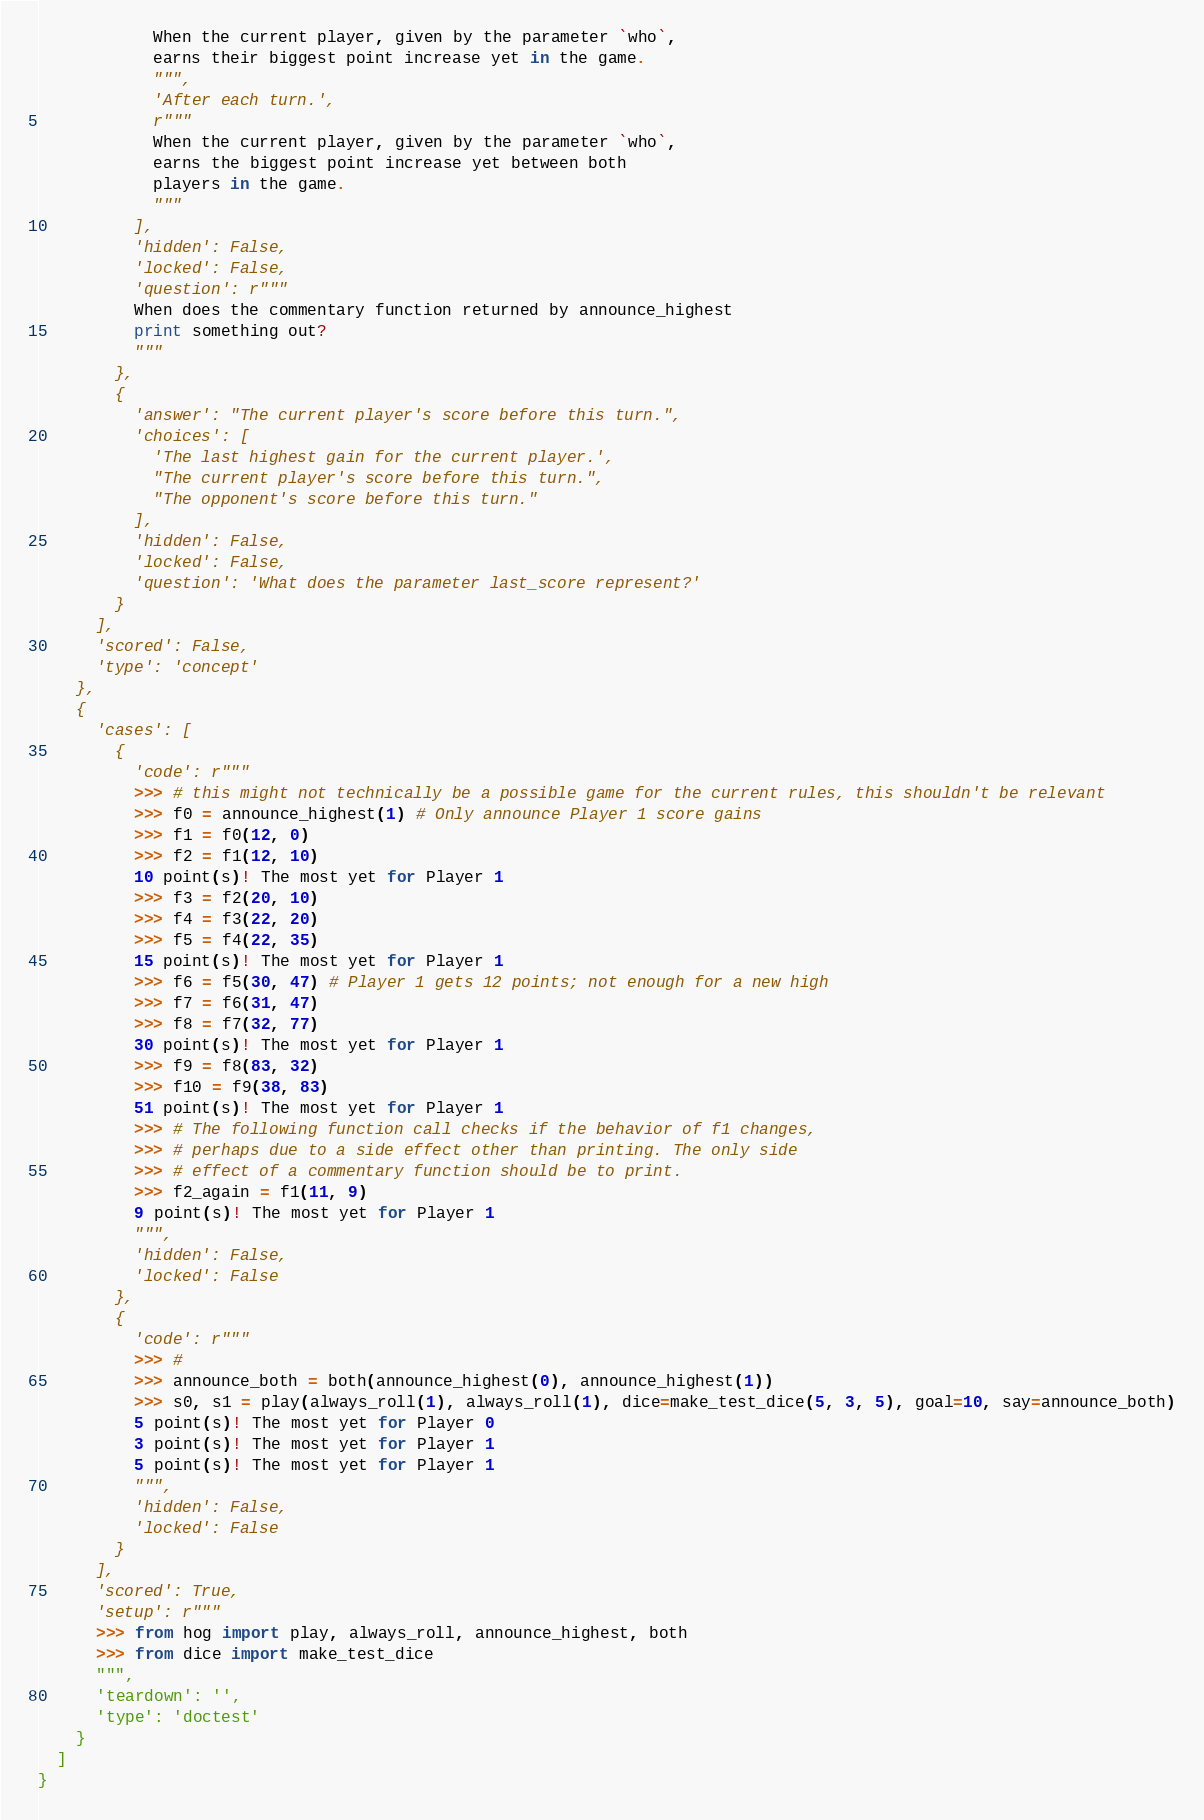<code> <loc_0><loc_0><loc_500><loc_500><_Python_>            When the current player, given by the parameter `who`,
            earns their biggest point increase yet in the game.
            """,
            'After each turn.',
            r"""
            When the current player, given by the parameter `who`,
            earns the biggest point increase yet between both
            players in the game.
            """
          ],
          'hidden': False,
          'locked': False,
          'question': r"""
          When does the commentary function returned by announce_highest
          print something out?
          """
        },
        {
          'answer': "The current player's score before this turn.",
          'choices': [
            'The last highest gain for the current player.',
            "The current player's score before this turn.",
            "The opponent's score before this turn."
          ],
          'hidden': False,
          'locked': False,
          'question': 'What does the parameter last_score represent?'
        }
      ],
      'scored': False,
      'type': 'concept'
    },
    {
      'cases': [
        {
          'code': r"""
          >>> # this might not technically be a possible game for the current rules, this shouldn't be relevant
          >>> f0 = announce_highest(1) # Only announce Player 1 score gains
          >>> f1 = f0(12, 0)
          >>> f2 = f1(12, 10)
          10 point(s)! The most yet for Player 1
          >>> f3 = f2(20, 10)
          >>> f4 = f3(22, 20)
          >>> f5 = f4(22, 35)
          15 point(s)! The most yet for Player 1
          >>> f6 = f5(30, 47) # Player 1 gets 12 points; not enough for a new high
          >>> f7 = f6(31, 47)
          >>> f8 = f7(32, 77)
          30 point(s)! The most yet for Player 1
          >>> f9 = f8(83, 32)
          >>> f10 = f9(38, 83)
          51 point(s)! The most yet for Player 1
          >>> # The following function call checks if the behavior of f1 changes,
          >>> # perhaps due to a side effect other than printing. The only side
          >>> # effect of a commentary function should be to print.
          >>> f2_again = f1(11, 9)
          9 point(s)! The most yet for Player 1
          """,
          'hidden': False,
          'locked': False
        },
        {
          'code': r"""
          >>> #
          >>> announce_both = both(announce_highest(0), announce_highest(1))
          >>> s0, s1 = play(always_roll(1), always_roll(1), dice=make_test_dice(5, 3, 5), goal=10, say=announce_both)
          5 point(s)! The most yet for Player 0
          3 point(s)! The most yet for Player 1
          5 point(s)! The most yet for Player 1
          """,
          'hidden': False,
          'locked': False
        }
      ],
      'scored': True,
      'setup': r"""
      >>> from hog import play, always_roll, announce_highest, both
      >>> from dice import make_test_dice
      """,
      'teardown': '',
      'type': 'doctest'
    }
  ]
}
</code> 